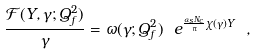<formula> <loc_0><loc_0><loc_500><loc_500>\frac { { \mathcal { F } } ( Y , \gamma ; Q _ { f } ^ { 2 } ) } { \gamma } = \omega ( \gamma ; Q _ { f } ^ { 2 } ) \ e ^ { \frac { \alpha _ { s } N _ { c } } { \pi } \chi ( \gamma ) Y } \ ,</formula> 